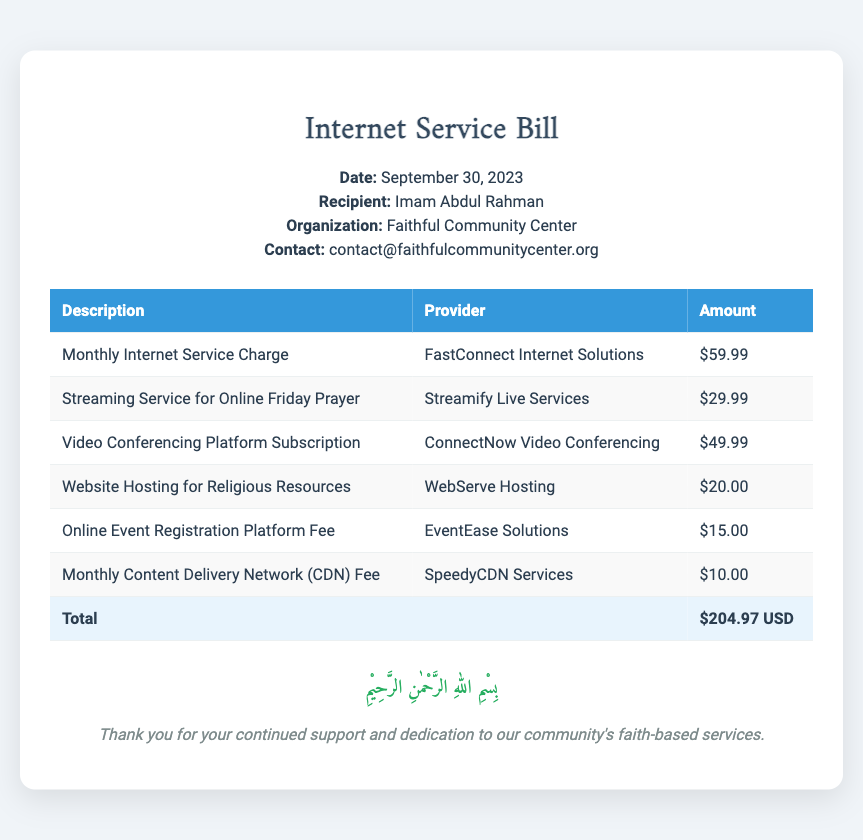What is the date of the bill? The date of the bill is mentioned in the document header as September 30, 2023.
Answer: September 30, 2023 Who is the recipient of the bill? The recipient of the bill is specified in the document header as Imam Abdul Rahman.
Answer: Imam Abdul Rahman What is the total amount charged? The total amount is highlighted in the charges table as the sum of all charges, listed as $204.97 USD.
Answer: $204.97 USD Which company provides the monthly internet service? The provider of the monthly internet service is stated in the table as FastConnect Internet Solutions.
Answer: FastConnect Internet Solutions How much is charged for the streaming service? The charge for the streaming service for online Friday prayer is listed in the charges table as $29.99.
Answer: $29.99 What is the purpose of the website hosting charge? The description in the document specifies the charge is for hosting religious resources.
Answer: Hosting religious resources Which service has the highest fee? The highest fee among the listed services in the document is for the Video Conferencing Platform Subscription at $49.99.
Answer: $49.99 How many types of services are itemized in the bill? The document itemizes a total of six different services in the charges table.
Answer: Six What is the fee for the online event registration platform? The fee for the online event registration platform is noted in the document as $15.00.
Answer: $15.00 What verse is highlighted at the bottom of the bill? The highlighted Arabic verse at the bottom of the document is a phrase of praise to God.
Answer: بِسْمِ اللهِ الرَّحْمٰنِ الرَّحِيْمِ 